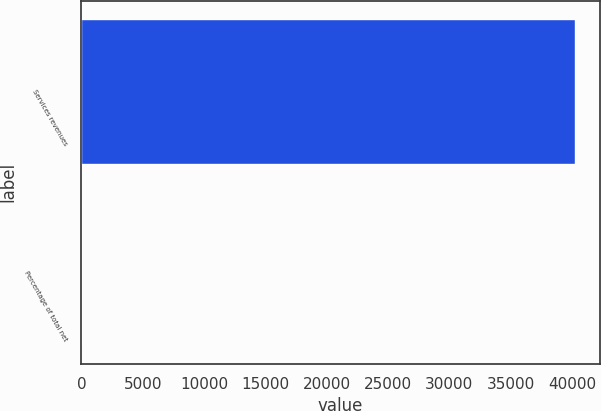Convert chart to OTSL. <chart><loc_0><loc_0><loc_500><loc_500><bar_chart><fcel>Services revenues<fcel>Percentage of total net<nl><fcel>40261<fcel>2<nl></chart> 